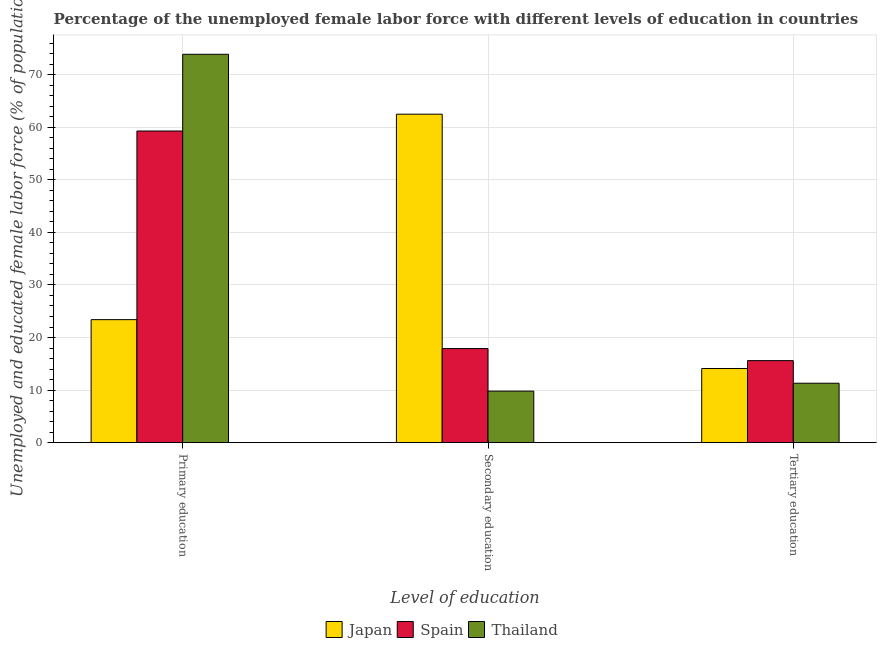Are the number of bars per tick equal to the number of legend labels?
Offer a very short reply. Yes. Are the number of bars on each tick of the X-axis equal?
Offer a terse response. Yes. How many bars are there on the 2nd tick from the left?
Keep it short and to the point. 3. What is the label of the 3rd group of bars from the left?
Offer a very short reply. Tertiary education. What is the percentage of female labor force who received primary education in Japan?
Offer a very short reply. 23.4. Across all countries, what is the maximum percentage of female labor force who received secondary education?
Your answer should be compact. 62.5. Across all countries, what is the minimum percentage of female labor force who received secondary education?
Keep it short and to the point. 9.8. In which country was the percentage of female labor force who received secondary education maximum?
Your answer should be compact. Japan. In which country was the percentage of female labor force who received tertiary education minimum?
Provide a succinct answer. Thailand. What is the total percentage of female labor force who received tertiary education in the graph?
Offer a very short reply. 41. What is the difference between the percentage of female labor force who received secondary education in Thailand and that in Spain?
Your answer should be very brief. -8.1. What is the difference between the percentage of female labor force who received primary education in Thailand and the percentage of female labor force who received secondary education in Spain?
Offer a terse response. 56. What is the average percentage of female labor force who received primary education per country?
Ensure brevity in your answer.  52.2. What is the difference between the percentage of female labor force who received tertiary education and percentage of female labor force who received primary education in Thailand?
Keep it short and to the point. -62.6. What is the ratio of the percentage of female labor force who received secondary education in Spain to that in Japan?
Offer a terse response. 0.29. Is the difference between the percentage of female labor force who received tertiary education in Japan and Thailand greater than the difference between the percentage of female labor force who received secondary education in Japan and Thailand?
Offer a terse response. No. What is the difference between the highest and the lowest percentage of female labor force who received primary education?
Provide a short and direct response. 50.5. What does the 1st bar from the right in Secondary education represents?
Your answer should be compact. Thailand. Is it the case that in every country, the sum of the percentage of female labor force who received primary education and percentage of female labor force who received secondary education is greater than the percentage of female labor force who received tertiary education?
Offer a terse response. Yes. What is the difference between two consecutive major ticks on the Y-axis?
Offer a very short reply. 10. Where does the legend appear in the graph?
Your answer should be compact. Bottom center. How are the legend labels stacked?
Ensure brevity in your answer.  Horizontal. What is the title of the graph?
Your response must be concise. Percentage of the unemployed female labor force with different levels of education in countries. What is the label or title of the X-axis?
Ensure brevity in your answer.  Level of education. What is the label or title of the Y-axis?
Your answer should be very brief. Unemployed and educated female labor force (% of population). What is the Unemployed and educated female labor force (% of population) of Japan in Primary education?
Offer a very short reply. 23.4. What is the Unemployed and educated female labor force (% of population) of Spain in Primary education?
Ensure brevity in your answer.  59.3. What is the Unemployed and educated female labor force (% of population) of Thailand in Primary education?
Your answer should be very brief. 73.9. What is the Unemployed and educated female labor force (% of population) of Japan in Secondary education?
Your answer should be very brief. 62.5. What is the Unemployed and educated female labor force (% of population) in Spain in Secondary education?
Make the answer very short. 17.9. What is the Unemployed and educated female labor force (% of population) of Thailand in Secondary education?
Offer a very short reply. 9.8. What is the Unemployed and educated female labor force (% of population) in Japan in Tertiary education?
Keep it short and to the point. 14.1. What is the Unemployed and educated female labor force (% of population) of Spain in Tertiary education?
Provide a succinct answer. 15.6. What is the Unemployed and educated female labor force (% of population) of Thailand in Tertiary education?
Your answer should be very brief. 11.3. Across all Level of education, what is the maximum Unemployed and educated female labor force (% of population) of Japan?
Ensure brevity in your answer.  62.5. Across all Level of education, what is the maximum Unemployed and educated female labor force (% of population) of Spain?
Give a very brief answer. 59.3. Across all Level of education, what is the maximum Unemployed and educated female labor force (% of population) of Thailand?
Offer a terse response. 73.9. Across all Level of education, what is the minimum Unemployed and educated female labor force (% of population) of Japan?
Offer a terse response. 14.1. Across all Level of education, what is the minimum Unemployed and educated female labor force (% of population) in Spain?
Provide a succinct answer. 15.6. Across all Level of education, what is the minimum Unemployed and educated female labor force (% of population) in Thailand?
Your response must be concise. 9.8. What is the total Unemployed and educated female labor force (% of population) of Japan in the graph?
Keep it short and to the point. 100. What is the total Unemployed and educated female labor force (% of population) in Spain in the graph?
Offer a very short reply. 92.8. What is the total Unemployed and educated female labor force (% of population) in Thailand in the graph?
Give a very brief answer. 95. What is the difference between the Unemployed and educated female labor force (% of population) of Japan in Primary education and that in Secondary education?
Provide a succinct answer. -39.1. What is the difference between the Unemployed and educated female labor force (% of population) in Spain in Primary education and that in Secondary education?
Provide a short and direct response. 41.4. What is the difference between the Unemployed and educated female labor force (% of population) of Thailand in Primary education and that in Secondary education?
Your answer should be very brief. 64.1. What is the difference between the Unemployed and educated female labor force (% of population) in Spain in Primary education and that in Tertiary education?
Keep it short and to the point. 43.7. What is the difference between the Unemployed and educated female labor force (% of population) in Thailand in Primary education and that in Tertiary education?
Your answer should be very brief. 62.6. What is the difference between the Unemployed and educated female labor force (% of population) of Japan in Secondary education and that in Tertiary education?
Your answer should be very brief. 48.4. What is the difference between the Unemployed and educated female labor force (% of population) in Thailand in Secondary education and that in Tertiary education?
Give a very brief answer. -1.5. What is the difference between the Unemployed and educated female labor force (% of population) in Japan in Primary education and the Unemployed and educated female labor force (% of population) in Spain in Secondary education?
Your response must be concise. 5.5. What is the difference between the Unemployed and educated female labor force (% of population) in Spain in Primary education and the Unemployed and educated female labor force (% of population) in Thailand in Secondary education?
Your answer should be very brief. 49.5. What is the difference between the Unemployed and educated female labor force (% of population) in Japan in Primary education and the Unemployed and educated female labor force (% of population) in Spain in Tertiary education?
Provide a short and direct response. 7.8. What is the difference between the Unemployed and educated female labor force (% of population) of Japan in Primary education and the Unemployed and educated female labor force (% of population) of Thailand in Tertiary education?
Your answer should be very brief. 12.1. What is the difference between the Unemployed and educated female labor force (% of population) in Japan in Secondary education and the Unemployed and educated female labor force (% of population) in Spain in Tertiary education?
Your answer should be very brief. 46.9. What is the difference between the Unemployed and educated female labor force (% of population) in Japan in Secondary education and the Unemployed and educated female labor force (% of population) in Thailand in Tertiary education?
Make the answer very short. 51.2. What is the difference between the Unemployed and educated female labor force (% of population) in Spain in Secondary education and the Unemployed and educated female labor force (% of population) in Thailand in Tertiary education?
Your answer should be very brief. 6.6. What is the average Unemployed and educated female labor force (% of population) of Japan per Level of education?
Give a very brief answer. 33.33. What is the average Unemployed and educated female labor force (% of population) in Spain per Level of education?
Ensure brevity in your answer.  30.93. What is the average Unemployed and educated female labor force (% of population) in Thailand per Level of education?
Provide a short and direct response. 31.67. What is the difference between the Unemployed and educated female labor force (% of population) in Japan and Unemployed and educated female labor force (% of population) in Spain in Primary education?
Provide a succinct answer. -35.9. What is the difference between the Unemployed and educated female labor force (% of population) in Japan and Unemployed and educated female labor force (% of population) in Thailand in Primary education?
Your response must be concise. -50.5. What is the difference between the Unemployed and educated female labor force (% of population) in Spain and Unemployed and educated female labor force (% of population) in Thailand in Primary education?
Make the answer very short. -14.6. What is the difference between the Unemployed and educated female labor force (% of population) in Japan and Unemployed and educated female labor force (% of population) in Spain in Secondary education?
Ensure brevity in your answer.  44.6. What is the difference between the Unemployed and educated female labor force (% of population) in Japan and Unemployed and educated female labor force (% of population) in Thailand in Secondary education?
Your response must be concise. 52.7. What is the difference between the Unemployed and educated female labor force (% of population) of Spain and Unemployed and educated female labor force (% of population) of Thailand in Secondary education?
Give a very brief answer. 8.1. What is the difference between the Unemployed and educated female labor force (% of population) of Japan and Unemployed and educated female labor force (% of population) of Spain in Tertiary education?
Your response must be concise. -1.5. What is the difference between the Unemployed and educated female labor force (% of population) of Japan and Unemployed and educated female labor force (% of population) of Thailand in Tertiary education?
Keep it short and to the point. 2.8. What is the ratio of the Unemployed and educated female labor force (% of population) of Japan in Primary education to that in Secondary education?
Provide a short and direct response. 0.37. What is the ratio of the Unemployed and educated female labor force (% of population) of Spain in Primary education to that in Secondary education?
Your answer should be very brief. 3.31. What is the ratio of the Unemployed and educated female labor force (% of population) in Thailand in Primary education to that in Secondary education?
Your response must be concise. 7.54. What is the ratio of the Unemployed and educated female labor force (% of population) of Japan in Primary education to that in Tertiary education?
Ensure brevity in your answer.  1.66. What is the ratio of the Unemployed and educated female labor force (% of population) in Spain in Primary education to that in Tertiary education?
Give a very brief answer. 3.8. What is the ratio of the Unemployed and educated female labor force (% of population) in Thailand in Primary education to that in Tertiary education?
Your answer should be compact. 6.54. What is the ratio of the Unemployed and educated female labor force (% of population) of Japan in Secondary education to that in Tertiary education?
Your answer should be compact. 4.43. What is the ratio of the Unemployed and educated female labor force (% of population) in Spain in Secondary education to that in Tertiary education?
Give a very brief answer. 1.15. What is the ratio of the Unemployed and educated female labor force (% of population) in Thailand in Secondary education to that in Tertiary education?
Provide a succinct answer. 0.87. What is the difference between the highest and the second highest Unemployed and educated female labor force (% of population) of Japan?
Keep it short and to the point. 39.1. What is the difference between the highest and the second highest Unemployed and educated female labor force (% of population) in Spain?
Make the answer very short. 41.4. What is the difference between the highest and the second highest Unemployed and educated female labor force (% of population) in Thailand?
Your answer should be compact. 62.6. What is the difference between the highest and the lowest Unemployed and educated female labor force (% of population) in Japan?
Ensure brevity in your answer.  48.4. What is the difference between the highest and the lowest Unemployed and educated female labor force (% of population) of Spain?
Give a very brief answer. 43.7. What is the difference between the highest and the lowest Unemployed and educated female labor force (% of population) in Thailand?
Make the answer very short. 64.1. 